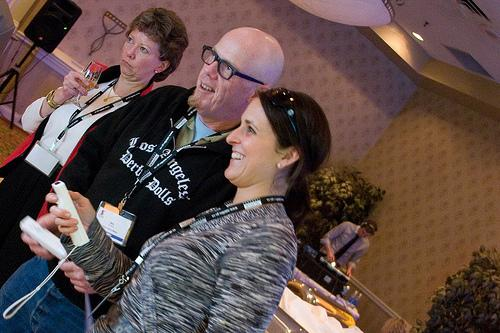What are the people in this image holding? The people in the image are holding game controllers. What can you say about the man's appearance in such a way that someone could identify him in the crowd? The man has no hair and is wearing glasses. What is a unique feature of the room this gathering is in? The room has ornate wallpaper on the walls and decorative inside tree bushes. What kind of event do you think these people are attending? These people are attending some kind of social event, possibly a company function. Can you describe the lady who is smiling? The lady who is smiling has short hair, sunglasses on her head, and is holding a wine glass. Briefly discuss the woman's outfit and accessories, including her shirt and lanyard. The woman is wearing a black and white shirt with a gold band around her wrist and a black and white lanyard around her neck. What type of object can be seen in the background of this scene? A black speaker on a tripod can be seen in the background. What can be said about the fashion choices of the attendees? Attendees are wearing a mix of casual and professional attire, including blue denim jeans, black jackets, ties, and lanyards. What does the woman standing near the man wearing a black tie have in her hand? The woman is holding a white remote, possibly a Wii controller. Which task does this image best fit for a product advertisement? The image best fits an advertisement for game controllers or a social gaming event. 